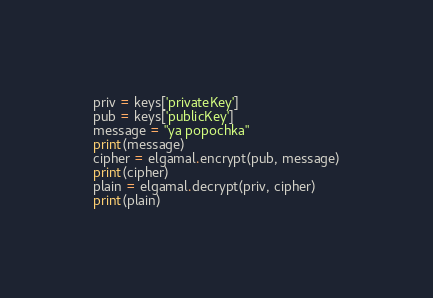Convert code to text. <code><loc_0><loc_0><loc_500><loc_500><_Python_>priv = keys['privateKey']
pub = keys['publicKey']
message = "ya popochka"
print(message)
cipher = elgamal.encrypt(pub, message)
print(cipher)
plain = elgamal.decrypt(priv, cipher)
print(plain)</code> 